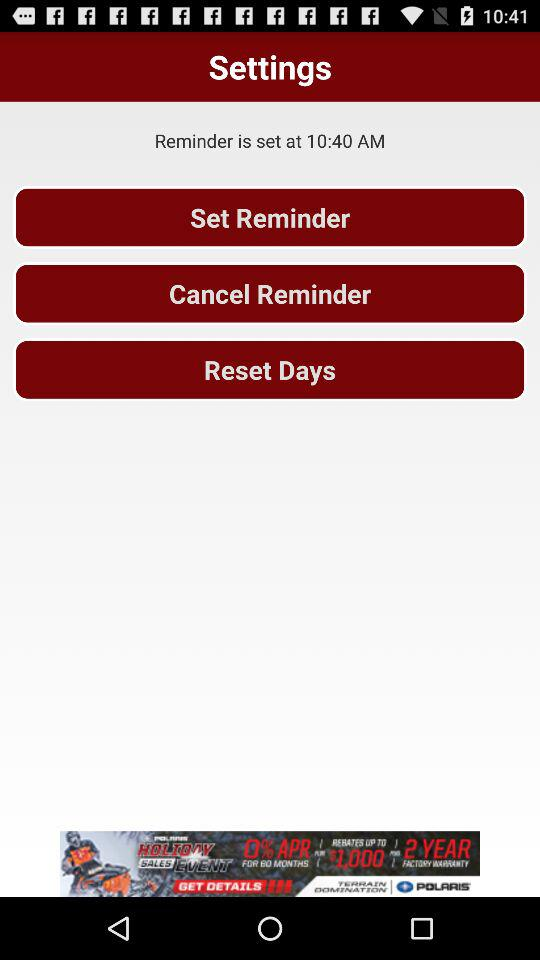At what time is the reminder set? The reminder is set at 10:40 AM. 